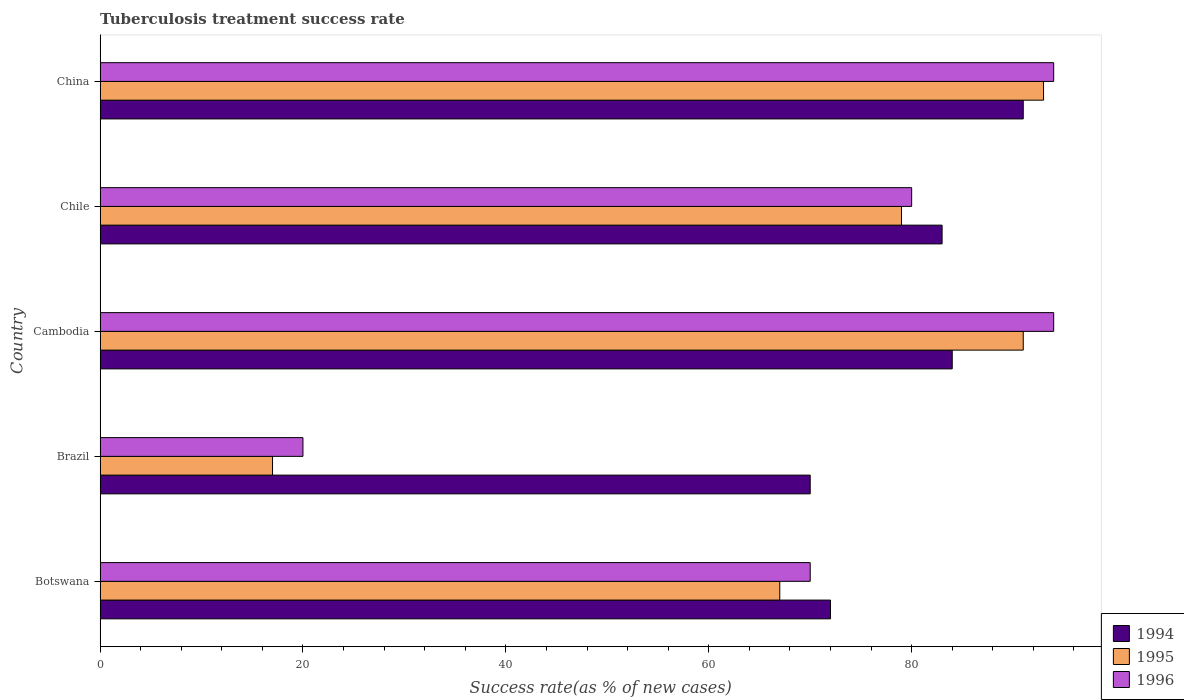How many groups of bars are there?
Provide a succinct answer. 5. Are the number of bars per tick equal to the number of legend labels?
Provide a succinct answer. Yes. How many bars are there on the 4th tick from the top?
Offer a very short reply. 3. How many bars are there on the 2nd tick from the bottom?
Your response must be concise. 3. What is the label of the 2nd group of bars from the top?
Offer a very short reply. Chile. In how many cases, is the number of bars for a given country not equal to the number of legend labels?
Ensure brevity in your answer.  0. Across all countries, what is the maximum tuberculosis treatment success rate in 1996?
Your answer should be very brief. 94. In which country was the tuberculosis treatment success rate in 1995 maximum?
Make the answer very short. China. In which country was the tuberculosis treatment success rate in 1994 minimum?
Keep it short and to the point. Brazil. What is the total tuberculosis treatment success rate in 1996 in the graph?
Your response must be concise. 358. What is the difference between the tuberculosis treatment success rate in 1996 in China and the tuberculosis treatment success rate in 1994 in Cambodia?
Provide a short and direct response. 10. In how many countries, is the tuberculosis treatment success rate in 1995 greater than 92 %?
Offer a terse response. 1. What is the ratio of the tuberculosis treatment success rate in 1995 in Chile to that in China?
Make the answer very short. 0.85. What is the difference between the highest and the second highest tuberculosis treatment success rate in 1995?
Make the answer very short. 2. Is the sum of the tuberculosis treatment success rate in 1994 in Botswana and Brazil greater than the maximum tuberculosis treatment success rate in 1995 across all countries?
Your response must be concise. Yes. Are all the bars in the graph horizontal?
Your answer should be very brief. Yes. What is the difference between two consecutive major ticks on the X-axis?
Your response must be concise. 20. Are the values on the major ticks of X-axis written in scientific E-notation?
Your answer should be compact. No. Does the graph contain grids?
Keep it short and to the point. No. How are the legend labels stacked?
Your answer should be very brief. Vertical. What is the title of the graph?
Give a very brief answer. Tuberculosis treatment success rate. What is the label or title of the X-axis?
Your response must be concise. Success rate(as % of new cases). What is the label or title of the Y-axis?
Offer a terse response. Country. What is the Success rate(as % of new cases) in 1995 in Botswana?
Provide a succinct answer. 67. What is the Success rate(as % of new cases) in 1996 in Botswana?
Provide a short and direct response. 70. What is the Success rate(as % of new cases) of 1996 in Brazil?
Make the answer very short. 20. What is the Success rate(as % of new cases) of 1994 in Cambodia?
Offer a very short reply. 84. What is the Success rate(as % of new cases) in 1995 in Cambodia?
Provide a short and direct response. 91. What is the Success rate(as % of new cases) of 1996 in Cambodia?
Your answer should be compact. 94. What is the Success rate(as % of new cases) of 1995 in Chile?
Offer a terse response. 79. What is the Success rate(as % of new cases) of 1996 in Chile?
Offer a terse response. 80. What is the Success rate(as % of new cases) of 1994 in China?
Your answer should be compact. 91. What is the Success rate(as % of new cases) of 1995 in China?
Offer a terse response. 93. What is the Success rate(as % of new cases) of 1996 in China?
Your answer should be compact. 94. Across all countries, what is the maximum Success rate(as % of new cases) in 1994?
Provide a succinct answer. 91. Across all countries, what is the maximum Success rate(as % of new cases) of 1995?
Your answer should be compact. 93. Across all countries, what is the maximum Success rate(as % of new cases) in 1996?
Keep it short and to the point. 94. Across all countries, what is the minimum Success rate(as % of new cases) of 1995?
Provide a succinct answer. 17. What is the total Success rate(as % of new cases) in 1995 in the graph?
Offer a very short reply. 347. What is the total Success rate(as % of new cases) in 1996 in the graph?
Your answer should be compact. 358. What is the difference between the Success rate(as % of new cases) in 1995 in Botswana and that in Brazil?
Provide a short and direct response. 50. What is the difference between the Success rate(as % of new cases) in 1994 in Botswana and that in Cambodia?
Make the answer very short. -12. What is the difference between the Success rate(as % of new cases) of 1995 in Botswana and that in Cambodia?
Ensure brevity in your answer.  -24. What is the difference between the Success rate(as % of new cases) in 1995 in Botswana and that in Chile?
Your response must be concise. -12. What is the difference between the Success rate(as % of new cases) in 1996 in Botswana and that in Chile?
Provide a succinct answer. -10. What is the difference between the Success rate(as % of new cases) in 1996 in Botswana and that in China?
Your answer should be compact. -24. What is the difference between the Success rate(as % of new cases) in 1994 in Brazil and that in Cambodia?
Provide a succinct answer. -14. What is the difference between the Success rate(as % of new cases) of 1995 in Brazil and that in Cambodia?
Your response must be concise. -74. What is the difference between the Success rate(as % of new cases) in 1996 in Brazil and that in Cambodia?
Provide a short and direct response. -74. What is the difference between the Success rate(as % of new cases) in 1994 in Brazil and that in Chile?
Your answer should be compact. -13. What is the difference between the Success rate(as % of new cases) of 1995 in Brazil and that in Chile?
Offer a terse response. -62. What is the difference between the Success rate(as % of new cases) in 1996 in Brazil and that in Chile?
Offer a terse response. -60. What is the difference between the Success rate(as % of new cases) in 1994 in Brazil and that in China?
Offer a very short reply. -21. What is the difference between the Success rate(as % of new cases) in 1995 in Brazil and that in China?
Provide a short and direct response. -76. What is the difference between the Success rate(as % of new cases) in 1996 in Brazil and that in China?
Offer a very short reply. -74. What is the difference between the Success rate(as % of new cases) of 1994 in Cambodia and that in Chile?
Offer a terse response. 1. What is the difference between the Success rate(as % of new cases) of 1994 in Cambodia and that in China?
Provide a short and direct response. -7. What is the difference between the Success rate(as % of new cases) of 1995 in Cambodia and that in China?
Keep it short and to the point. -2. What is the difference between the Success rate(as % of new cases) in 1994 in Chile and that in China?
Ensure brevity in your answer.  -8. What is the difference between the Success rate(as % of new cases) in 1995 in Chile and that in China?
Offer a very short reply. -14. What is the difference between the Success rate(as % of new cases) in 1994 in Botswana and the Success rate(as % of new cases) in 1996 in Cambodia?
Your response must be concise. -22. What is the difference between the Success rate(as % of new cases) in 1995 in Botswana and the Success rate(as % of new cases) in 1996 in Cambodia?
Provide a short and direct response. -27. What is the difference between the Success rate(as % of new cases) in 1995 in Botswana and the Success rate(as % of new cases) in 1996 in Chile?
Ensure brevity in your answer.  -13. What is the difference between the Success rate(as % of new cases) of 1994 in Brazil and the Success rate(as % of new cases) of 1995 in Cambodia?
Your answer should be compact. -21. What is the difference between the Success rate(as % of new cases) of 1994 in Brazil and the Success rate(as % of new cases) of 1996 in Cambodia?
Provide a short and direct response. -24. What is the difference between the Success rate(as % of new cases) in 1995 in Brazil and the Success rate(as % of new cases) in 1996 in Cambodia?
Make the answer very short. -77. What is the difference between the Success rate(as % of new cases) of 1994 in Brazil and the Success rate(as % of new cases) of 1996 in Chile?
Your response must be concise. -10. What is the difference between the Success rate(as % of new cases) in 1995 in Brazil and the Success rate(as % of new cases) in 1996 in Chile?
Make the answer very short. -63. What is the difference between the Success rate(as % of new cases) of 1995 in Brazil and the Success rate(as % of new cases) of 1996 in China?
Provide a short and direct response. -77. What is the difference between the Success rate(as % of new cases) in 1995 in Cambodia and the Success rate(as % of new cases) in 1996 in Chile?
Provide a short and direct response. 11. What is the difference between the Success rate(as % of new cases) in 1994 in Cambodia and the Success rate(as % of new cases) in 1996 in China?
Ensure brevity in your answer.  -10. What is the difference between the Success rate(as % of new cases) of 1995 in Cambodia and the Success rate(as % of new cases) of 1996 in China?
Offer a very short reply. -3. What is the difference between the Success rate(as % of new cases) in 1994 in Chile and the Success rate(as % of new cases) in 1995 in China?
Offer a terse response. -10. What is the difference between the Success rate(as % of new cases) of 1994 in Chile and the Success rate(as % of new cases) of 1996 in China?
Your response must be concise. -11. What is the difference between the Success rate(as % of new cases) in 1995 in Chile and the Success rate(as % of new cases) in 1996 in China?
Give a very brief answer. -15. What is the average Success rate(as % of new cases) of 1994 per country?
Ensure brevity in your answer.  80. What is the average Success rate(as % of new cases) in 1995 per country?
Your answer should be compact. 69.4. What is the average Success rate(as % of new cases) of 1996 per country?
Make the answer very short. 71.6. What is the difference between the Success rate(as % of new cases) of 1994 and Success rate(as % of new cases) of 1995 in Botswana?
Your answer should be very brief. 5. What is the difference between the Success rate(as % of new cases) of 1994 and Success rate(as % of new cases) of 1996 in Cambodia?
Your answer should be compact. -10. What is the difference between the Success rate(as % of new cases) of 1994 and Success rate(as % of new cases) of 1996 in Chile?
Your answer should be compact. 3. What is the difference between the Success rate(as % of new cases) of 1994 and Success rate(as % of new cases) of 1995 in China?
Ensure brevity in your answer.  -2. What is the difference between the Success rate(as % of new cases) in 1995 and Success rate(as % of new cases) in 1996 in China?
Offer a terse response. -1. What is the ratio of the Success rate(as % of new cases) of 1994 in Botswana to that in Brazil?
Ensure brevity in your answer.  1.03. What is the ratio of the Success rate(as % of new cases) of 1995 in Botswana to that in Brazil?
Your response must be concise. 3.94. What is the ratio of the Success rate(as % of new cases) in 1994 in Botswana to that in Cambodia?
Give a very brief answer. 0.86. What is the ratio of the Success rate(as % of new cases) of 1995 in Botswana to that in Cambodia?
Your answer should be compact. 0.74. What is the ratio of the Success rate(as % of new cases) of 1996 in Botswana to that in Cambodia?
Provide a short and direct response. 0.74. What is the ratio of the Success rate(as % of new cases) of 1994 in Botswana to that in Chile?
Your response must be concise. 0.87. What is the ratio of the Success rate(as % of new cases) in 1995 in Botswana to that in Chile?
Ensure brevity in your answer.  0.85. What is the ratio of the Success rate(as % of new cases) in 1994 in Botswana to that in China?
Offer a terse response. 0.79. What is the ratio of the Success rate(as % of new cases) in 1995 in Botswana to that in China?
Ensure brevity in your answer.  0.72. What is the ratio of the Success rate(as % of new cases) in 1996 in Botswana to that in China?
Keep it short and to the point. 0.74. What is the ratio of the Success rate(as % of new cases) in 1994 in Brazil to that in Cambodia?
Your answer should be compact. 0.83. What is the ratio of the Success rate(as % of new cases) of 1995 in Brazil to that in Cambodia?
Offer a terse response. 0.19. What is the ratio of the Success rate(as % of new cases) in 1996 in Brazil to that in Cambodia?
Keep it short and to the point. 0.21. What is the ratio of the Success rate(as % of new cases) in 1994 in Brazil to that in Chile?
Your answer should be compact. 0.84. What is the ratio of the Success rate(as % of new cases) of 1995 in Brazil to that in Chile?
Offer a terse response. 0.22. What is the ratio of the Success rate(as % of new cases) in 1996 in Brazil to that in Chile?
Your answer should be compact. 0.25. What is the ratio of the Success rate(as % of new cases) in 1994 in Brazil to that in China?
Keep it short and to the point. 0.77. What is the ratio of the Success rate(as % of new cases) of 1995 in Brazil to that in China?
Offer a terse response. 0.18. What is the ratio of the Success rate(as % of new cases) of 1996 in Brazil to that in China?
Your response must be concise. 0.21. What is the ratio of the Success rate(as % of new cases) of 1995 in Cambodia to that in Chile?
Give a very brief answer. 1.15. What is the ratio of the Success rate(as % of new cases) in 1996 in Cambodia to that in Chile?
Make the answer very short. 1.18. What is the ratio of the Success rate(as % of new cases) of 1994 in Cambodia to that in China?
Offer a very short reply. 0.92. What is the ratio of the Success rate(as % of new cases) in 1995 in Cambodia to that in China?
Give a very brief answer. 0.98. What is the ratio of the Success rate(as % of new cases) of 1996 in Cambodia to that in China?
Keep it short and to the point. 1. What is the ratio of the Success rate(as % of new cases) of 1994 in Chile to that in China?
Your answer should be compact. 0.91. What is the ratio of the Success rate(as % of new cases) in 1995 in Chile to that in China?
Provide a succinct answer. 0.85. What is the ratio of the Success rate(as % of new cases) in 1996 in Chile to that in China?
Offer a terse response. 0.85. What is the difference between the highest and the second highest Success rate(as % of new cases) in 1994?
Offer a terse response. 7. What is the difference between the highest and the lowest Success rate(as % of new cases) in 1994?
Provide a succinct answer. 21. What is the difference between the highest and the lowest Success rate(as % of new cases) in 1996?
Your response must be concise. 74. 